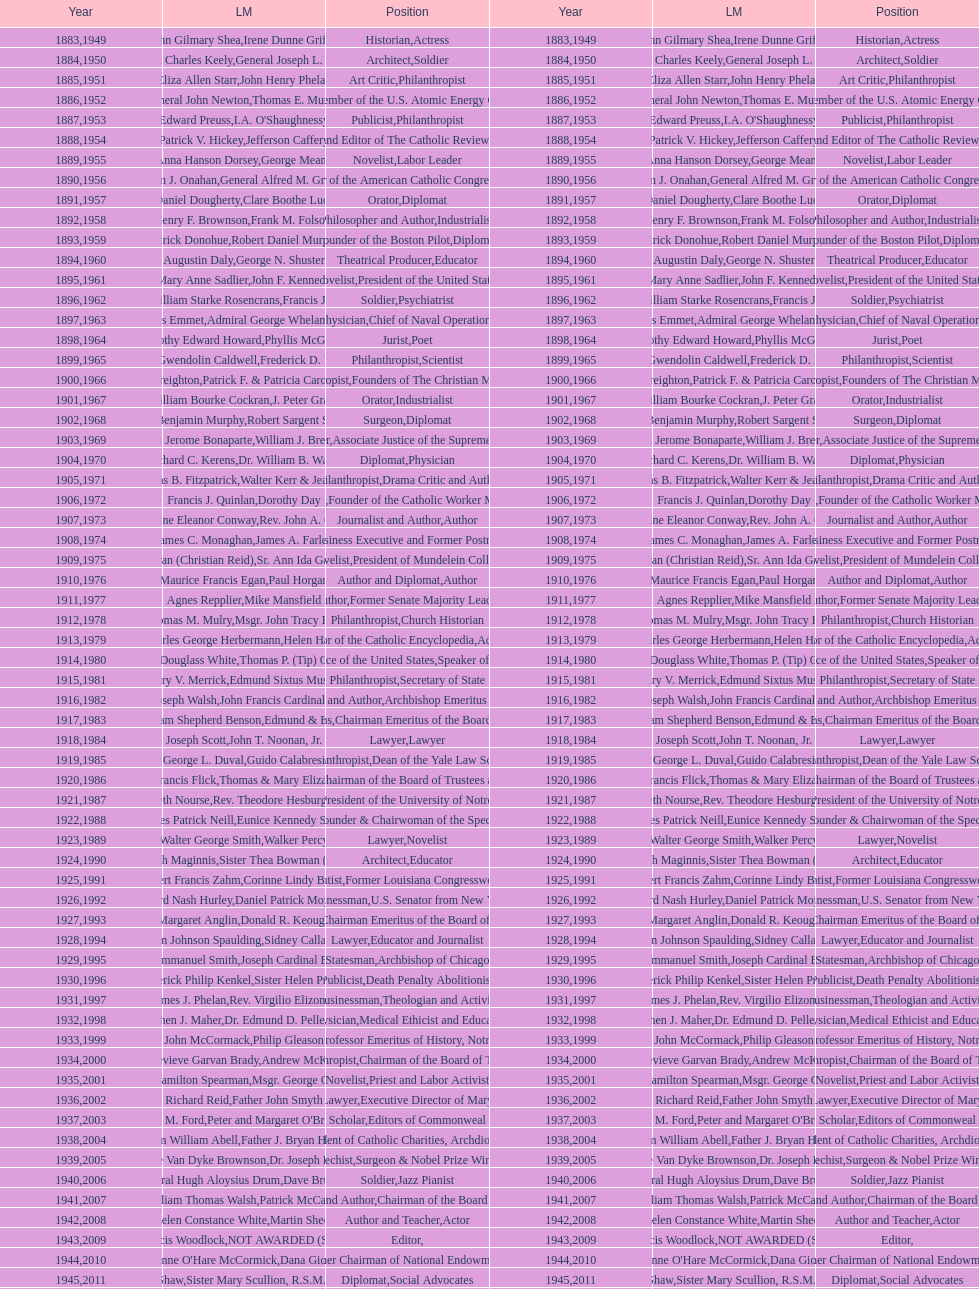How many lawyers have won the award between 1883 and 2014? 5. 